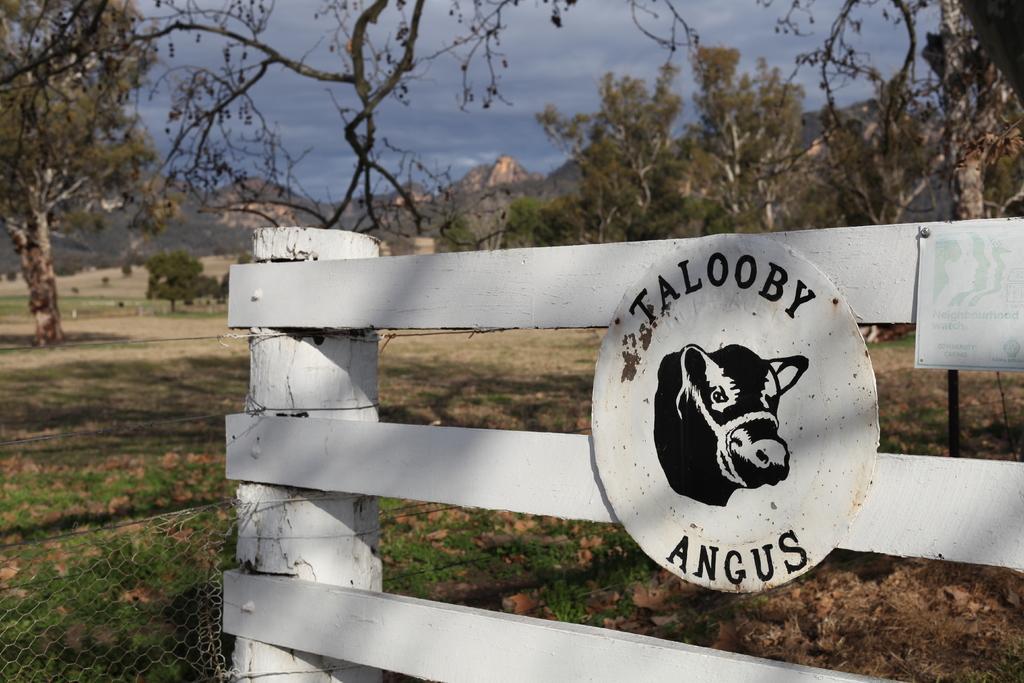Could you give a brief overview of what you see in this image? In this image, we can see a board with some text and a logo and there is a poster and we can see a fence. In the background, there are trees and hills. At the top, there is sky and at the bottom, there is ground. 